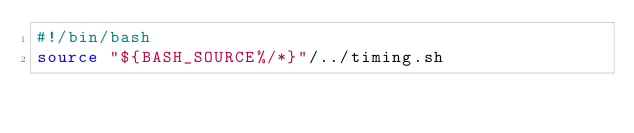<code> <loc_0><loc_0><loc_500><loc_500><_Bash_>#!/bin/bash
source "${BASH_SOURCE%/*}"/../timing.sh
</code> 